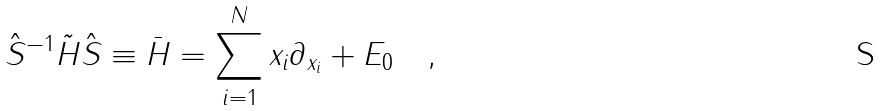Convert formula to latex. <formula><loc_0><loc_0><loc_500><loc_500>\hat { S } ^ { - 1 } \tilde { H } \hat { S } \equiv \bar { H } = \sum _ { i = 1 } ^ { N } x _ { i } \partial _ { x _ { i } } + E _ { 0 } \quad ,</formula> 